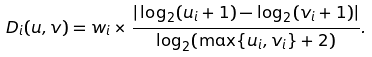<formula> <loc_0><loc_0><loc_500><loc_500>D _ { i } ( u , v ) = w _ { i } \times \frac { | \log _ { 2 } ( u _ { i } + 1 ) - \log _ { 2 } ( v _ { i } + 1 ) | } { \log _ { 2 } ( \max \{ u _ { i } , v _ { i } \} + 2 ) } .</formula> 